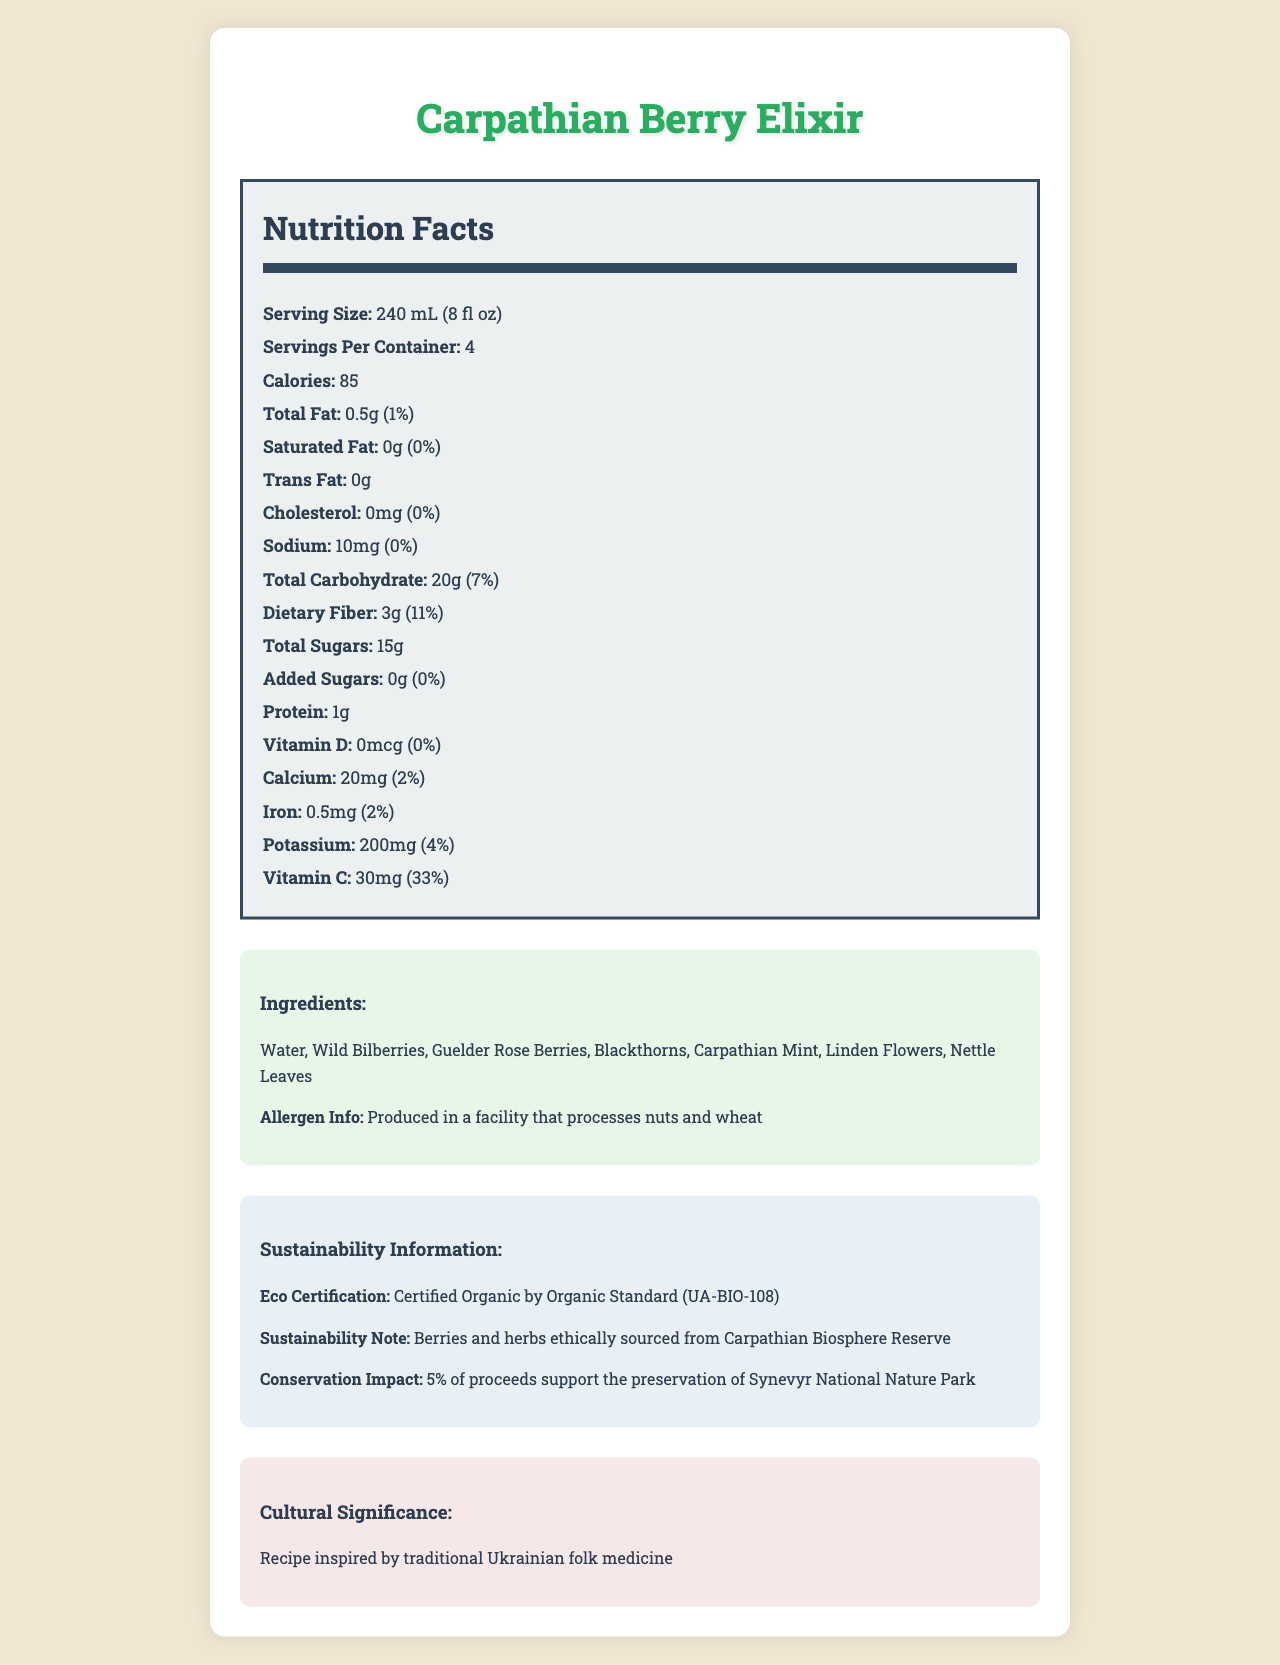what is the serving size? The serving size is mentioned at the top of the Nutrition Facts section, listed as 240 mL (8 fl oz).
Answer: 240 mL (8 fl oz) how many calories are there per serving? The calories per serving are listed as 85, just below the serving size.
Answer: 85 what is the total fat content per serving? The total fat content per serving is listed as 0.5g.
Answer: 0.5g is there any added sugar in the beverage? The amount of added sugars is listed as 0g, which means there are no added sugars.
Answer: No how much vitamin C does one serving provide? One serving provides 30mg of vitamin C, as mentioned in the Nutrition Facts section.
Answer: 30mg what are the main ingredients in the Carpathian Berry Elixir? These ingredients are listed under the Ingredients section.
Answer: Water, Wild Bilberries, Guelder Rose Berries, Blackthorns, Carpathian Mint, Linden Flowers, Nettle Leaves which of the following ingredients are not part of the Carpathian Berry Elixir? A. Nettle Leaves B. Guelder Rose Berries C. Blueberries D. Blackthorns Blueberries are not listed as one of the ingredients. The other options are all part of the ingredients list.
Answer: C. Blueberries how much dietary fiber is present in one serving? A. 1g B. 3g C. 5g D. 7g The dietary fiber content per serving is listed as 3g.
Answer: B. 3g does the beverage contain any allergens? The allergen info states that it is produced in a facility that processes nuts and wheat.
Answer: Yes is the Carpathian Berry Elixir certified organic? It is certified organic by Organic Standard (UA-BIO-108), as mentioned in the Sustainability Information section.
Answer: Yes how many servings are there per container? There are 4 servings per container, as stated near the top of the Nutrition Facts section.
Answer: 4 what is the primary cultural significance of the beverage? The cultural significance section states that the recipe is inspired by traditional Ukrainian folk medicine.
Answer: Recipe inspired by traditional Ukrainian folk medicine what is the total carbohydrate content per serving? The total carbohydrate content per serving is listed as 20g.
Answer: 20g how many grams of protein are in a serving? Each serving contains 1g of protein.
Answer: 1g explain the sustainability practices associated with the product. The Sustainability Information section details that the ingredients are ethically sourced and that a portion of proceeds supports environmental preservation.
Answer: The berries and herbs are ethically sourced from the Carpathian Biosphere Reserve, and 5% of the proceeds support the preservation of Synevyr National Nature Park. what are the main components of the document? The main components are sections detailing the nutritional content, ingredients, allergen information, sustainability practices, and cultural significance, all centered around the Carpathian Berry Elixir.
Answer: The document includes the product name, serving size, servings per container, nutrition facts, ingredients, allergen info, sustainability information, and cultural significance. what proportion of daily iron requirement does one serving of this beverage provide? The Iron content per serving is listed, with its daily value being 2%.
Answer: 2% what environmental cause does the product support? This information is provided in the Sustainability Information section.
Answer: 5% of proceeds support the preservation of Synevyr National Nature Park are there any details about the local history of the berries used in the beverage? The document does not provide any specific details about the local history of the berries used in the beverage.
Answer: Not enough information is there any cholesterol in the beverage? The cholesterol content is listed as 0mg, indicating there is no cholesterol in the beverage.
Answer: No summarize the entire document This summary incorporates key details from various sections of the document, including nutritional content, ingredients, sustainability efforts, and cultural significance.
Answer: The Carpathian Berry Elixir is a beverage made from wild berries and herbs sourced from protected natural areas in the Carpathian Biosphere Reserve. It serves 4 per container with 85 calories per serving. The drink does not contain significant amounts of fat, cholesterol, or added sugars, while providing dietary fiber, vitamin C, and small amounts of calcium, iron, and potassium. The ingredients include Water, Wild Bilberries, Guelder Rose Berries, Blackthorns, Carpathian Mint, Linden Flowers, and Nettle Leaves. The product is certified organic, carries cultural significance as it follows traditional Ukrainian folk medicine, and supports sustainability by contributing to the preservation of Synevyr National Nature Park. 